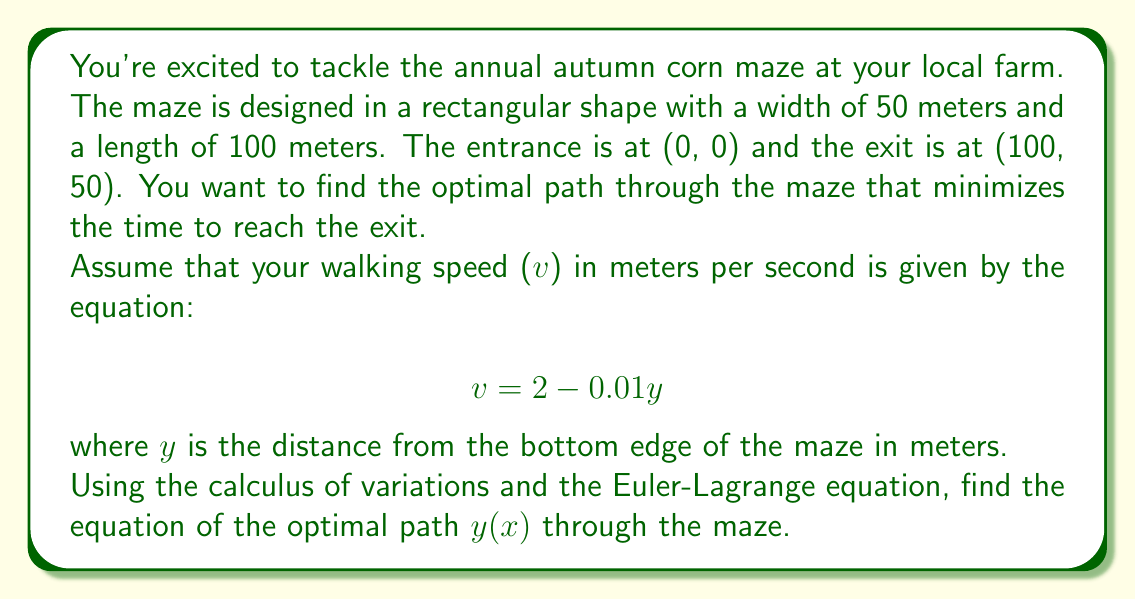Help me with this question. To solve this problem, we'll use the calculus of variations and the Euler-Lagrange equation. Let's break it down step-by-step:

1) First, we need to set up our functional. The time taken to traverse a small segment of the path is given by:

   $dt = \frac{ds}{v}$

   where ds is the length of the path segment.

2) We can express ds in terms of dx and dy:

   $ds = \sqrt{dx^2 + dy^2} = dx\sqrt{1 + (\frac{dy}{dx})^2} = dx\sqrt{1 + y'^2}$

3) The total time T is the integral of dt:

   $T = \int_0^{100} \frac{\sqrt{1 + y'^2}}{2 - 0.01y} dx$

4) This is our functional to minimize. Let's call the integrand F:

   $F(x, y, y') = \frac{\sqrt{1 + y'^2}}{2 - 0.01y}$

5) The Euler-Lagrange equation is:

   $\frac{\partial F}{\partial y} - \frac{d}{dx}(\frac{\partial F}{\partial y'}) = 0$

6) Let's calculate the partial derivatives:

   $\frac{\partial F}{\partial y} = \frac{0.01\sqrt{1 + y'^2}}{(2 - 0.01y)^2}$

   $\frac{\partial F}{\partial y'} = \frac{y'}{(2 - 0.01y)\sqrt{1 + y'^2}}$

7) Now, let's substitute these into the Euler-Lagrange equation:

   $\frac{0.01\sqrt{1 + y'^2}}{(2 - 0.01y)^2} - \frac{d}{dx}(\frac{y'}{(2 - 0.01y)\sqrt{1 + y'^2}}) = 0$

8) This is a complicated differential equation. However, we can simplify it by noticing that F doesn't explicitly depend on x. This means we have a first integral:

   $F - y'\frac{\partial F}{\partial y'} = C$

   where C is a constant.

9) Substituting our F and its partial derivative:

   $\frac{\sqrt{1 + y'^2}}{2 - 0.01y} - \frac{y'^2}{(2 - 0.01y)\sqrt{1 + y'^2}} = C$

10) Simplifying:

    $\frac{1}{(2 - 0.01y)\sqrt{1 + y'^2}} = C$

11) Solving for y':

    $y' = \pm \sqrt{\frac{1}{C^2(2 - 0.01y)^2} - 1}$

12) This is a separable differential equation. Solving it (and choosing the positive root as we're moving upwards):

    $y = 200 - \frac{200}{\sqrt{1 + C^2x^2}}$

13) We can find C using the boundary conditions. We know y(0) = 0 and y(100) = 50. Using y(100) = 50:

    $50 = 200 - \frac{200}{\sqrt{1 + 10000C^2}}$

    Solving this gives us $C = \frac{\sqrt{3}}{300}$.

Therefore, the equation of the optimal path is:

$y = 200 - \frac{200}{\sqrt{1 + \frac{x^2}{30000}}}$
Answer: $y = 200 - \frac{200}{\sqrt{1 + \frac{x^2}{30000}}}$ 